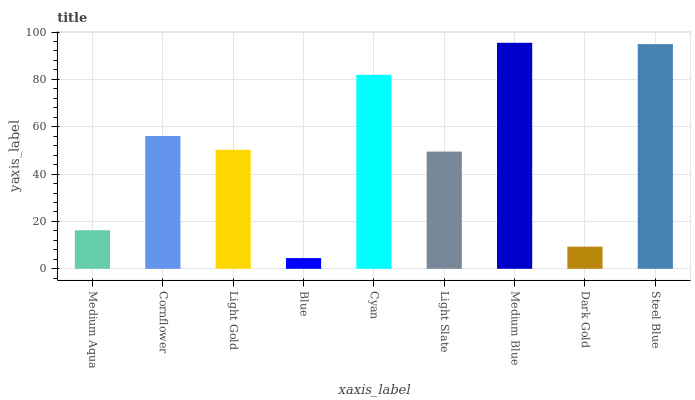Is Cornflower the minimum?
Answer yes or no. No. Is Cornflower the maximum?
Answer yes or no. No. Is Cornflower greater than Medium Aqua?
Answer yes or no. Yes. Is Medium Aqua less than Cornflower?
Answer yes or no. Yes. Is Medium Aqua greater than Cornflower?
Answer yes or no. No. Is Cornflower less than Medium Aqua?
Answer yes or no. No. Is Light Gold the high median?
Answer yes or no. Yes. Is Light Gold the low median?
Answer yes or no. Yes. Is Medium Aqua the high median?
Answer yes or no. No. Is Cornflower the low median?
Answer yes or no. No. 